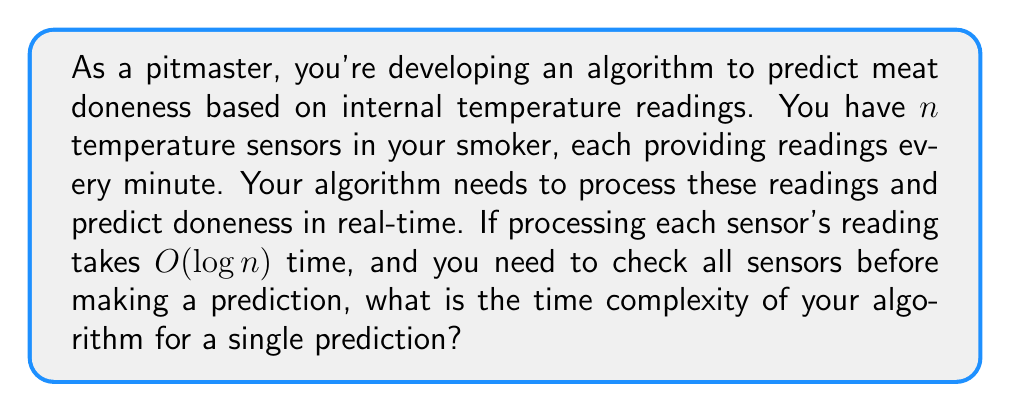Could you help me with this problem? Let's break this down step-by-step:

1) We have $n$ temperature sensors.

2) Each sensor's reading takes $O(\log n)$ time to process.

3) We need to process all $n$ sensors before making a prediction.

4) To find the total time complexity, we need to multiply the number of operations (processing each sensor) by the time complexity of each operation:

   $n \cdot O(\log n)$

5) In Big O notation, this simplifies to:

   $O(n \log n)$

This is because when we have a product of functions in Big O notation, we keep the term with the highest growth rate. In this case, $n \log n$ grows faster than just $n$ or just $\log n$.

6) Therefore, the time complexity for a single prediction is $O(n \log n)$.

This means that as the number of sensors increases, the time to make a prediction will increase at a rate slightly faster than linear, but not as fast as quadratic. This is generally considered an efficient algorithm, especially for sorting and data processing tasks.
Answer: $O(n \log n)$ 